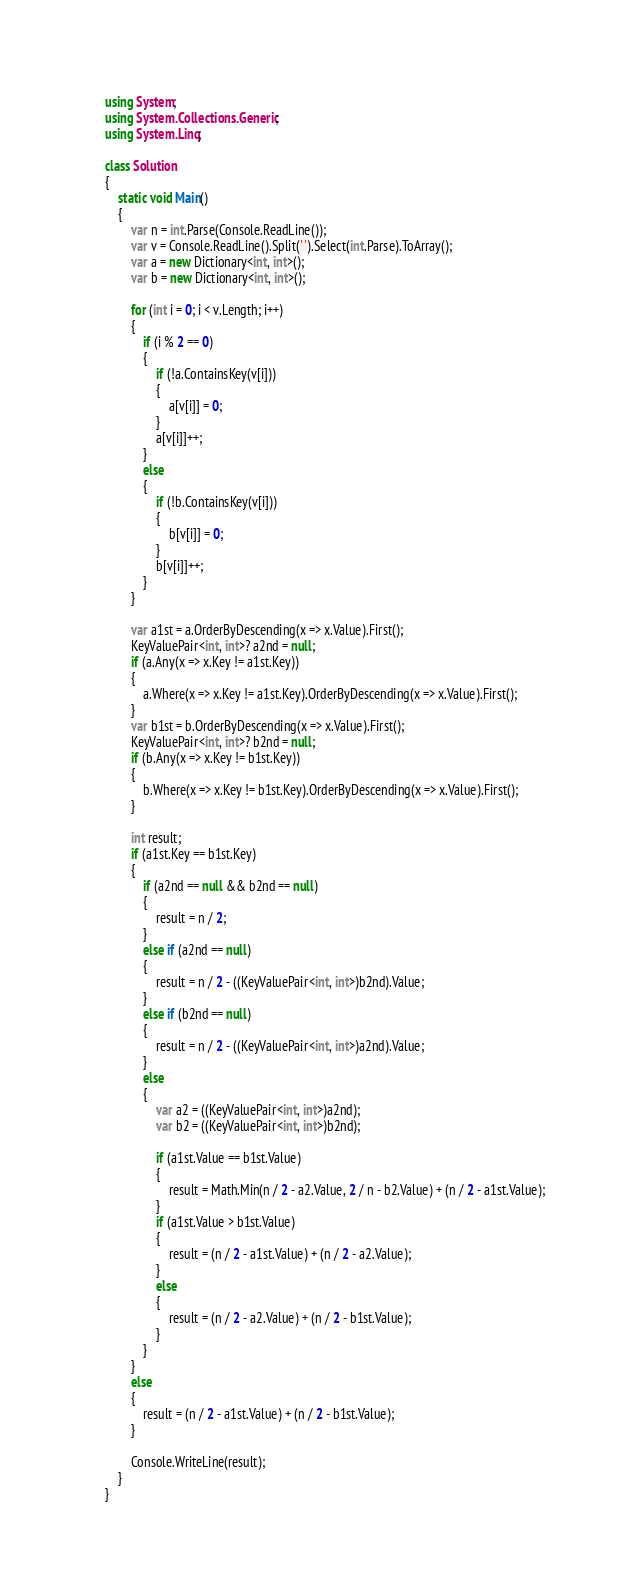<code> <loc_0><loc_0><loc_500><loc_500><_C#_>using System;
using System.Collections.Generic;
using System.Linq;

class Solution
{
    static void Main()
    {
        var n = int.Parse(Console.ReadLine());
        var v = Console.ReadLine().Split(' ').Select(int.Parse).ToArray();
        var a = new Dictionary<int, int>();
        var b = new Dictionary<int, int>();

        for (int i = 0; i < v.Length; i++)
        {
            if (i % 2 == 0)
            {
                if (!a.ContainsKey(v[i]))
                {
                    a[v[i]] = 0;
                }
                a[v[i]]++;
            }
            else
            {
                if (!b.ContainsKey(v[i]))
                {
                    b[v[i]] = 0;
                }
                b[v[i]]++;
            }
        }

        var a1st = a.OrderByDescending(x => x.Value).First();
        KeyValuePair<int, int>? a2nd = null;
        if (a.Any(x => x.Key != a1st.Key))
        {
            a.Where(x => x.Key != a1st.Key).OrderByDescending(x => x.Value).First();
        }
        var b1st = b.OrderByDescending(x => x.Value).First();
        KeyValuePair<int, int>? b2nd = null;
        if (b.Any(x => x.Key != b1st.Key))
        {
            b.Where(x => x.Key != b1st.Key).OrderByDescending(x => x.Value).First();
        }

        int result;
        if (a1st.Key == b1st.Key)
        {
            if (a2nd == null && b2nd == null)
            {
                result = n / 2;
            }
            else if (a2nd == null)
            {
                result = n / 2 - ((KeyValuePair<int, int>)b2nd).Value;
            }
            else if (b2nd == null)
            {
                result = n / 2 - ((KeyValuePair<int, int>)a2nd).Value;
            }
            else
            {
                var a2 = ((KeyValuePair<int, int>)a2nd);
                var b2 = ((KeyValuePair<int, int>)b2nd);

                if (a1st.Value == b1st.Value)
                {
                    result = Math.Min(n / 2 - a2.Value, 2 / n - b2.Value) + (n / 2 - a1st.Value);
                }
                if (a1st.Value > b1st.Value)
                {
                    result = (n / 2 - a1st.Value) + (n / 2 - a2.Value);
                }
                else
                {
                    result = (n / 2 - a2.Value) + (n / 2 - b1st.Value);
                }
            }
        }
        else
        {
            result = (n / 2 - a1st.Value) + (n / 2 - b1st.Value);
        }

        Console.WriteLine(result);
    }
}</code> 